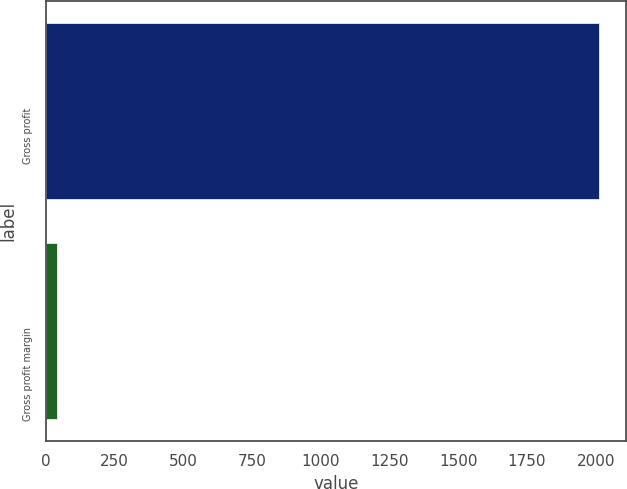Convert chart to OTSL. <chart><loc_0><loc_0><loc_500><loc_500><bar_chart><fcel>Gross profit<fcel>Gross profit margin<nl><fcel>2010.2<fcel>41.6<nl></chart> 